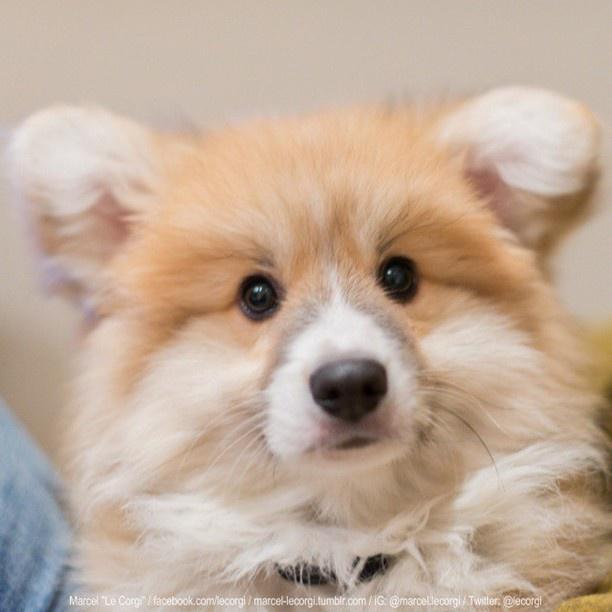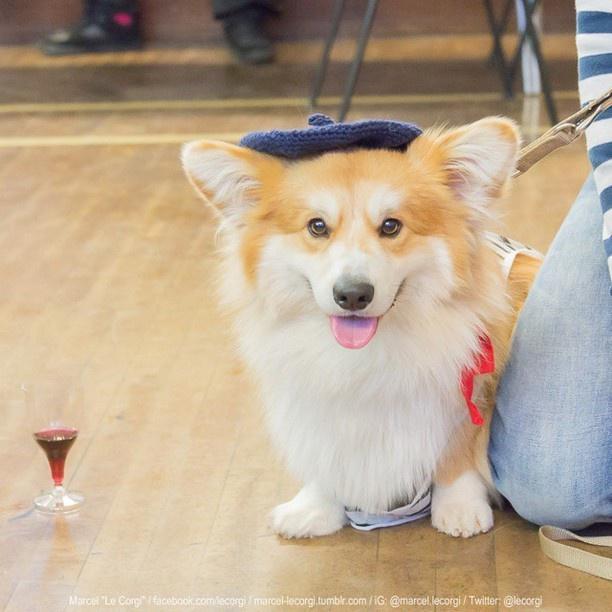The first image is the image on the left, the second image is the image on the right. Examine the images to the left and right. Is the description "One of the dogs is shown with holiday decoration." accurate? Answer yes or no. No. The first image is the image on the left, the second image is the image on the right. Examine the images to the left and right. Is the description "One photo shows a dog outdoors." accurate? Answer yes or no. No. 